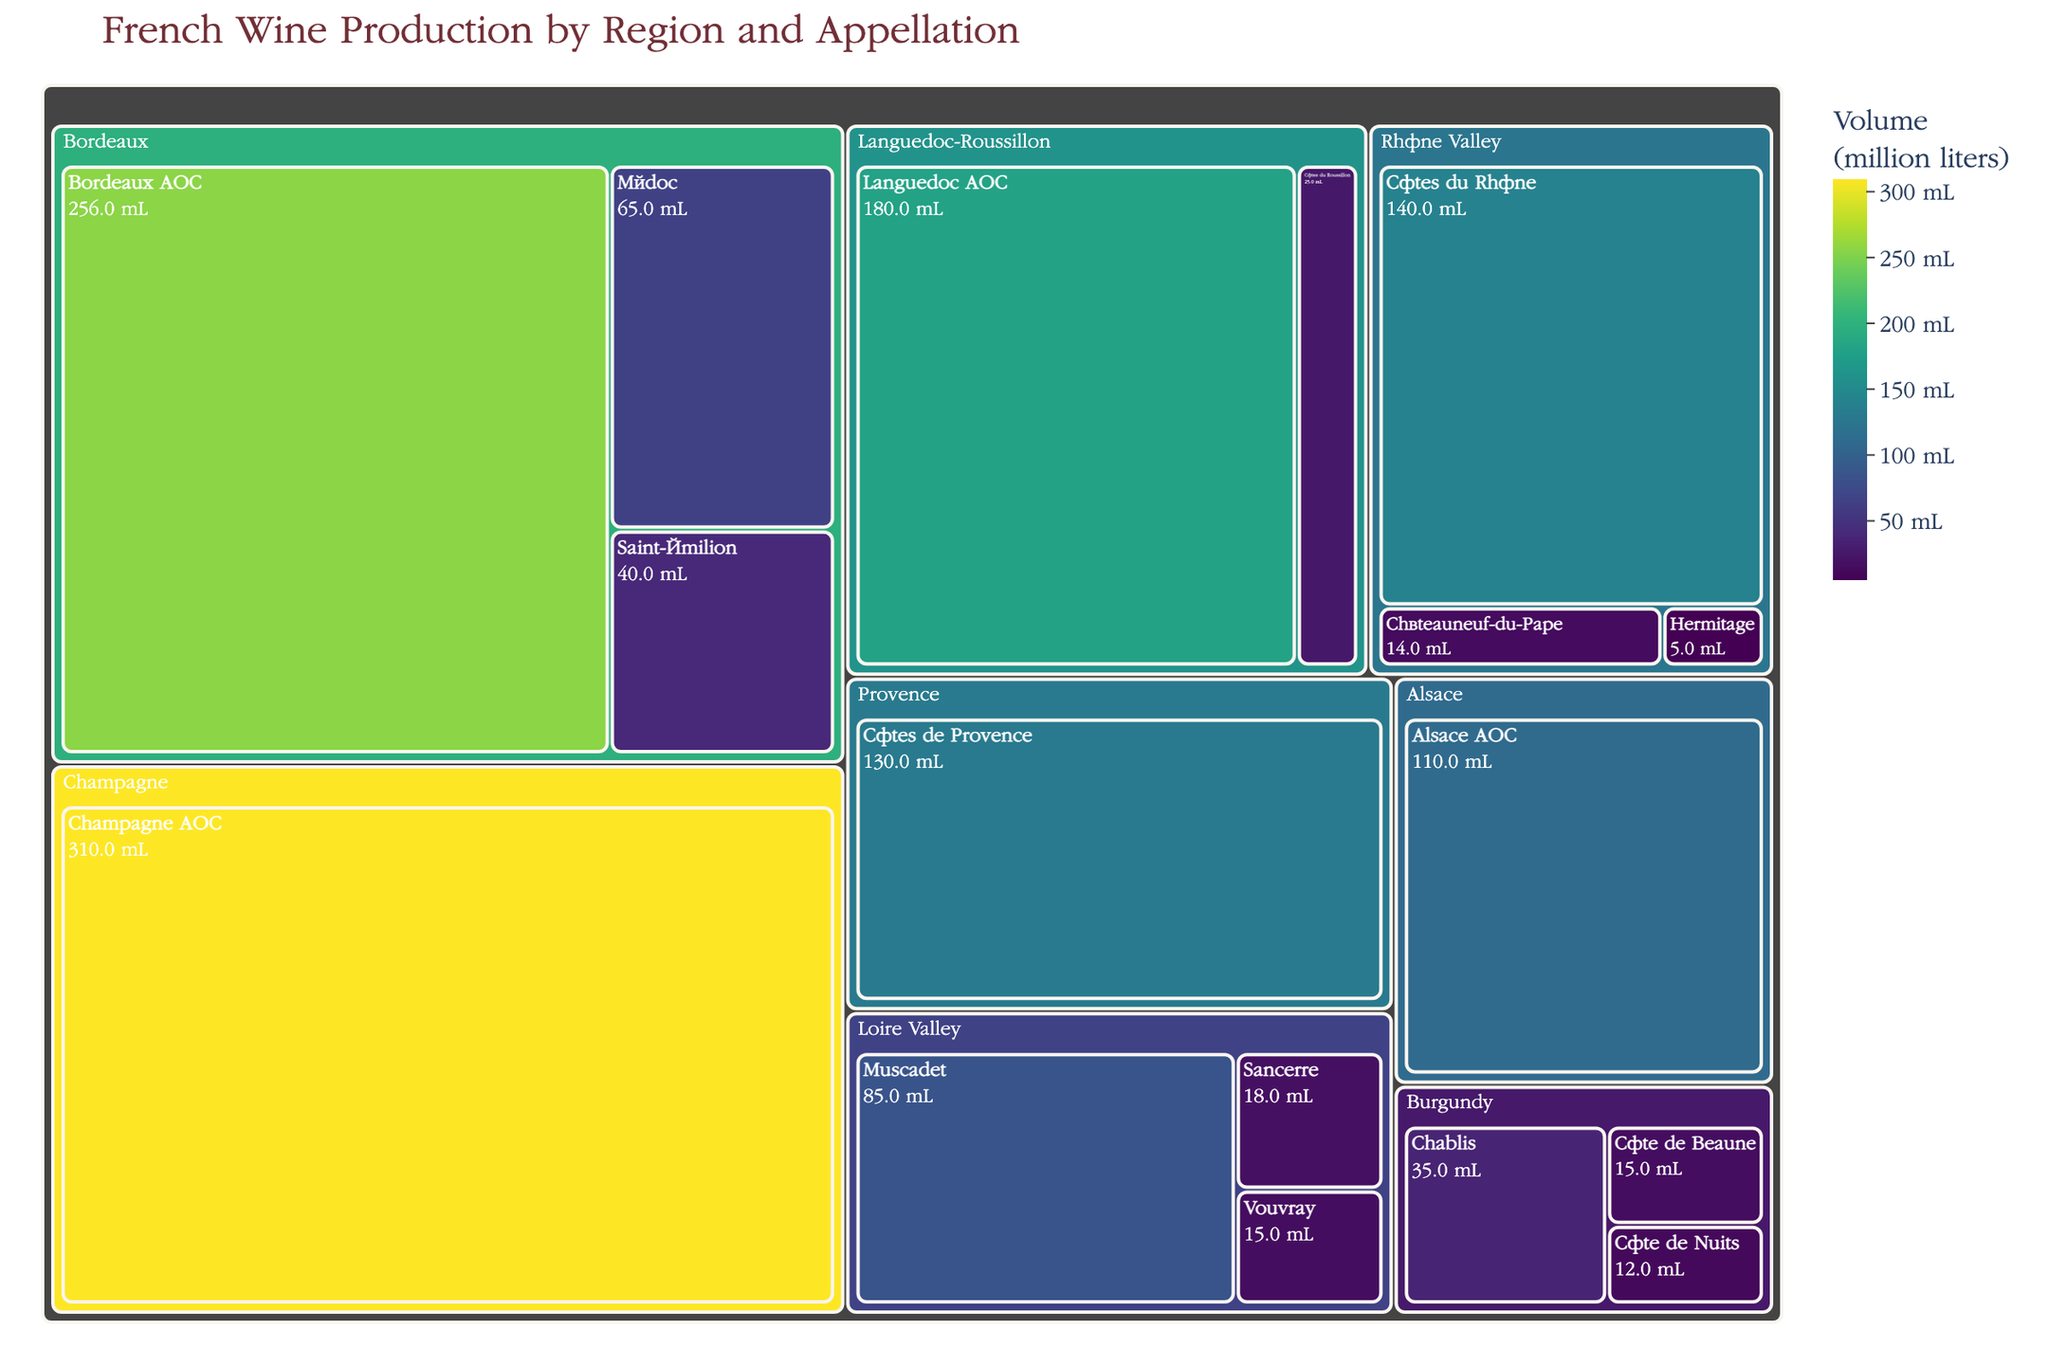What's the highest wine production volume by region? The treemap clearly shows that Champagne has the highest wine production volume with Champagne AOC producing 310 million liters.
Answer: Champagne How much wine does the Bordeaux region produce in total? The volumes for Bordeaux AOC, Médoc, and Saint-Émilion in Bordeaux add up to 256 + 65 + 40 = 361 million liters.
Answer: 361 million liters Which region produces the least amount of wine by a single appellation? The Rhône Valley's Hermitage produces the least at 5 million liters.
Answer: Rhône Valley How do the wine production volumes of the Rhône Valley and Languedoc-Roussillon compare? Adding up for Rhône Valley: Côtes du Rhône (140) + Châteauneuf-du-Pape (14) + Hermitage (5) = 159 million liters, and for Languedoc-Roussillon: Languedoc AOC (180) + Côtes du Roussillon (25) = 205 million liters. So, Languedoc-Roussillon produces more.
Answer: Languedoc-Roussillon produces more What's the combined wine production volume of all Burgundy appellations? Summing the production volumes for Chablis, Côte de Beaune, and Côte de Nuits in Burgundy gives 35 + 15 + 12 = 62 million liters.
Answer: 62 million liters Which Loire Valley appellation has the highest production volume? Among the appellations in Loire Valley, Muscadet has the highest volume with 85 million liters.
Answer: Muscadet What is the difference in production volume between Bordeaux AOC in Bordeaux and Côtes de Provence in Provence? Bordeaux AOC produces 256 million liters while Côtes de Provence produces 130 million liters. The difference is 256 - 130 = 126 million liters.
Answer: 126 million liters Identify the three regions with the highest aggregated wine production volumes. Summing production for each region shows that Champagne (310 million liters), Languedoc-Roussillon (205 million liters), and Bordeaux (361 million liters) have the highest. Bordeaux, though, leads overall.
Answer: Bordeaux, Champagne, Languedoc-Roussillon 